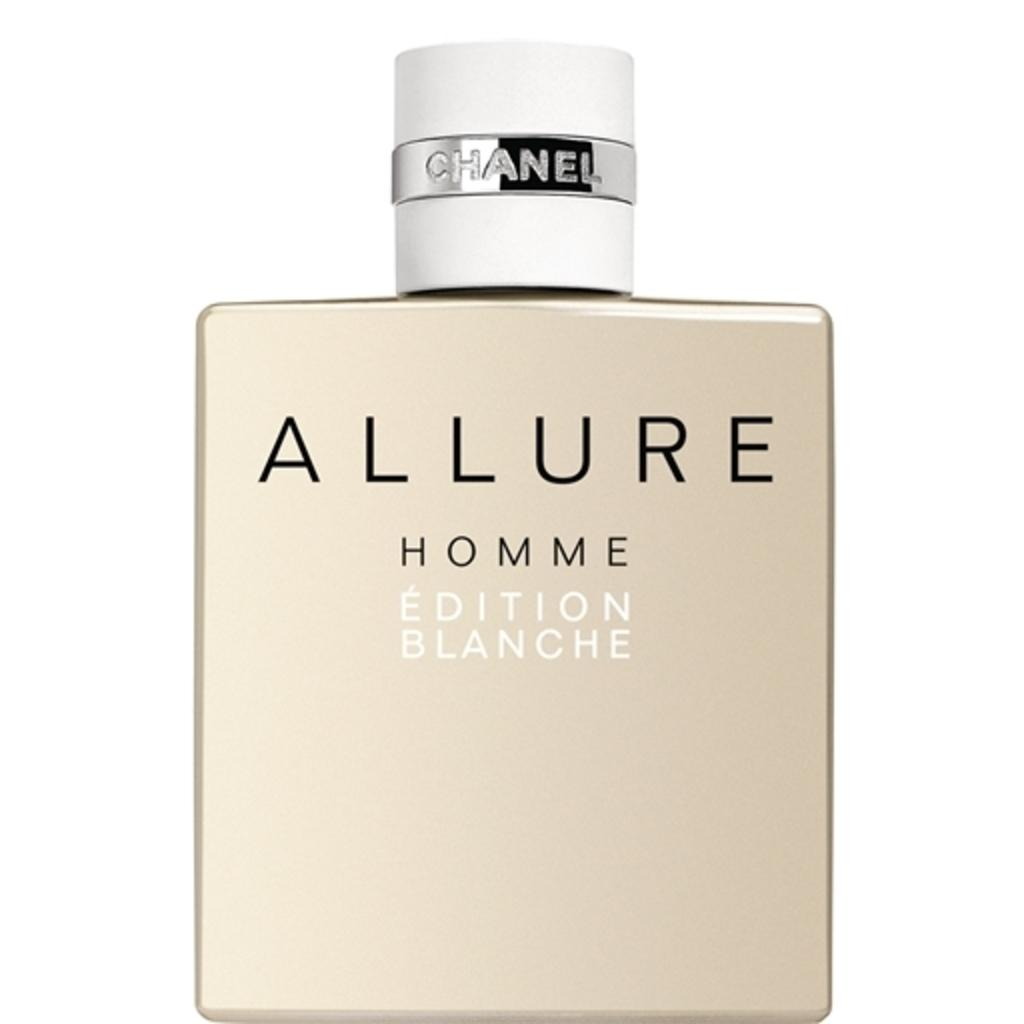Provide a one-sentence caption for the provided image. A bottle of perfume called Allure by Chanel. 